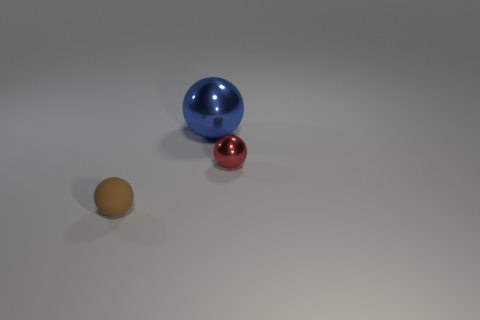There is a tiny ball in front of the small red sphere; how many tiny matte balls are in front of it?
Make the answer very short. 0. There is a red sphere that is the same size as the brown matte thing; what is its material?
Offer a very short reply. Metal. How many other objects are the same material as the large blue ball?
Provide a short and direct response. 1. There is a blue shiny sphere; how many tiny things are left of it?
Ensure brevity in your answer.  1. What number of blocks are big blue things or metallic things?
Offer a very short reply. 0. There is a sphere that is both in front of the blue metal thing and on the left side of the small metallic object; how big is it?
Give a very brief answer. Small. Do the large ball and the tiny sphere on the right side of the small brown thing have the same material?
Provide a short and direct response. Yes. How many things are tiny balls right of the big blue ball or big blue shiny spheres?
Your answer should be very brief. 2. Are there any other things that are the same size as the brown matte ball?
Give a very brief answer. Yes. What is the size of the blue sphere that is made of the same material as the tiny red ball?
Offer a terse response. Large. 